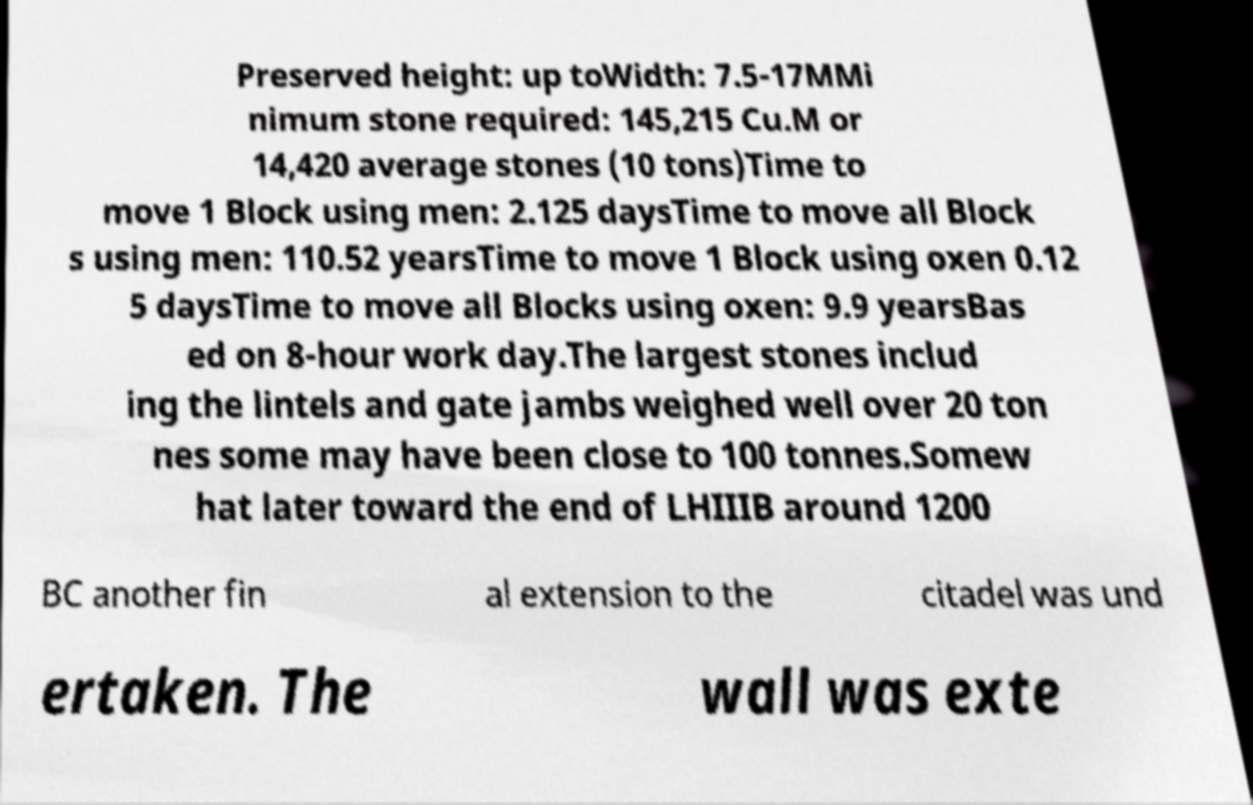There's text embedded in this image that I need extracted. Can you transcribe it verbatim? Preserved height: up toWidth: 7.5-17MMi nimum stone required: 145,215 Cu.M or 14,420 average stones (10 tons)Time to move 1 Block using men: 2.125 daysTime to move all Block s using men: 110.52 yearsTime to move 1 Block using oxen 0.12 5 daysTime to move all Blocks using oxen: 9.9 yearsBas ed on 8-hour work day.The largest stones includ ing the lintels and gate jambs weighed well over 20 ton nes some may have been close to 100 tonnes.Somew hat later toward the end of LHIIIB around 1200 BC another fin al extension to the citadel was und ertaken. The wall was exte 